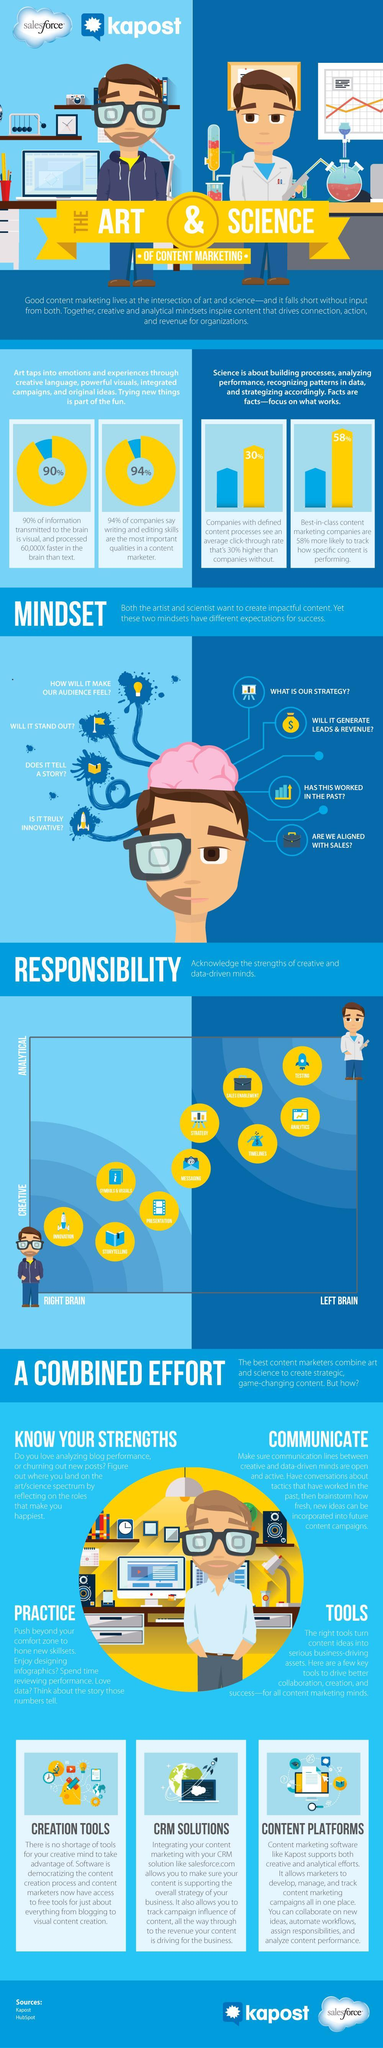Which part is explored by the right brain
Answer the question with a short phrase. creative What percentage of information transmitted to the brain is not visual? 10% Which part is explored by the left brain analytical how faster is visual information processed when compared to text 60,000X What is explored with the light bulb icon in content writing how will it make our audience feel? 